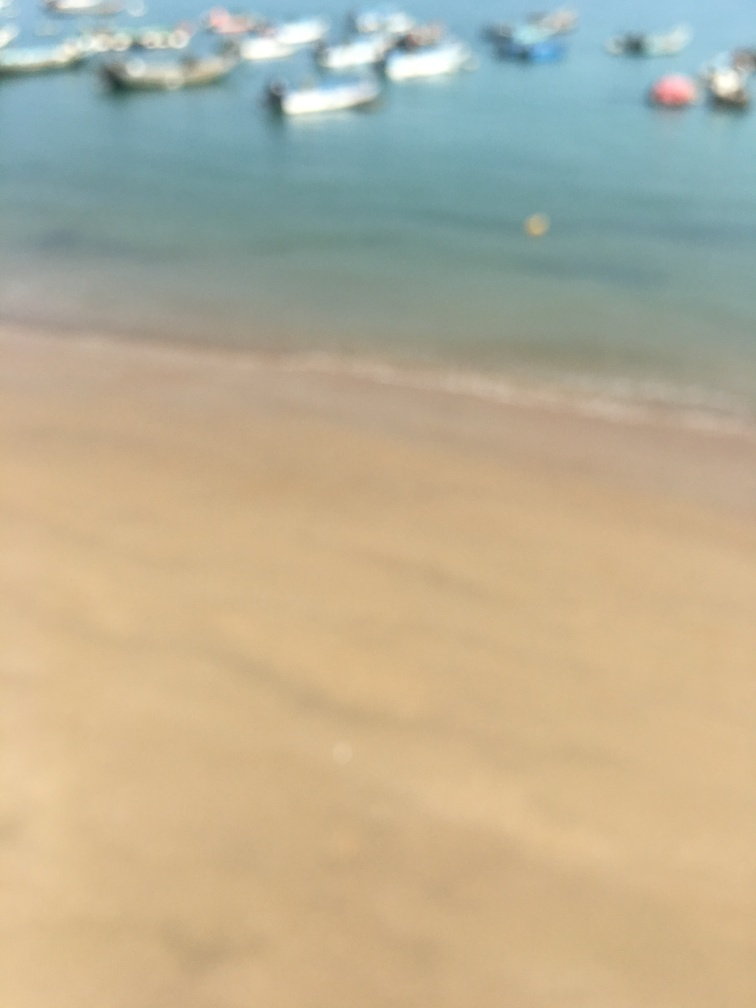Does the image give any indication of the weather at the beach? The bright tones and lack of dark shadows in the image suggest a sunny day with clear weather, which is typical for beach environments. 